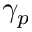Convert formula to latex. <formula><loc_0><loc_0><loc_500><loc_500>\gamma _ { p }</formula> 